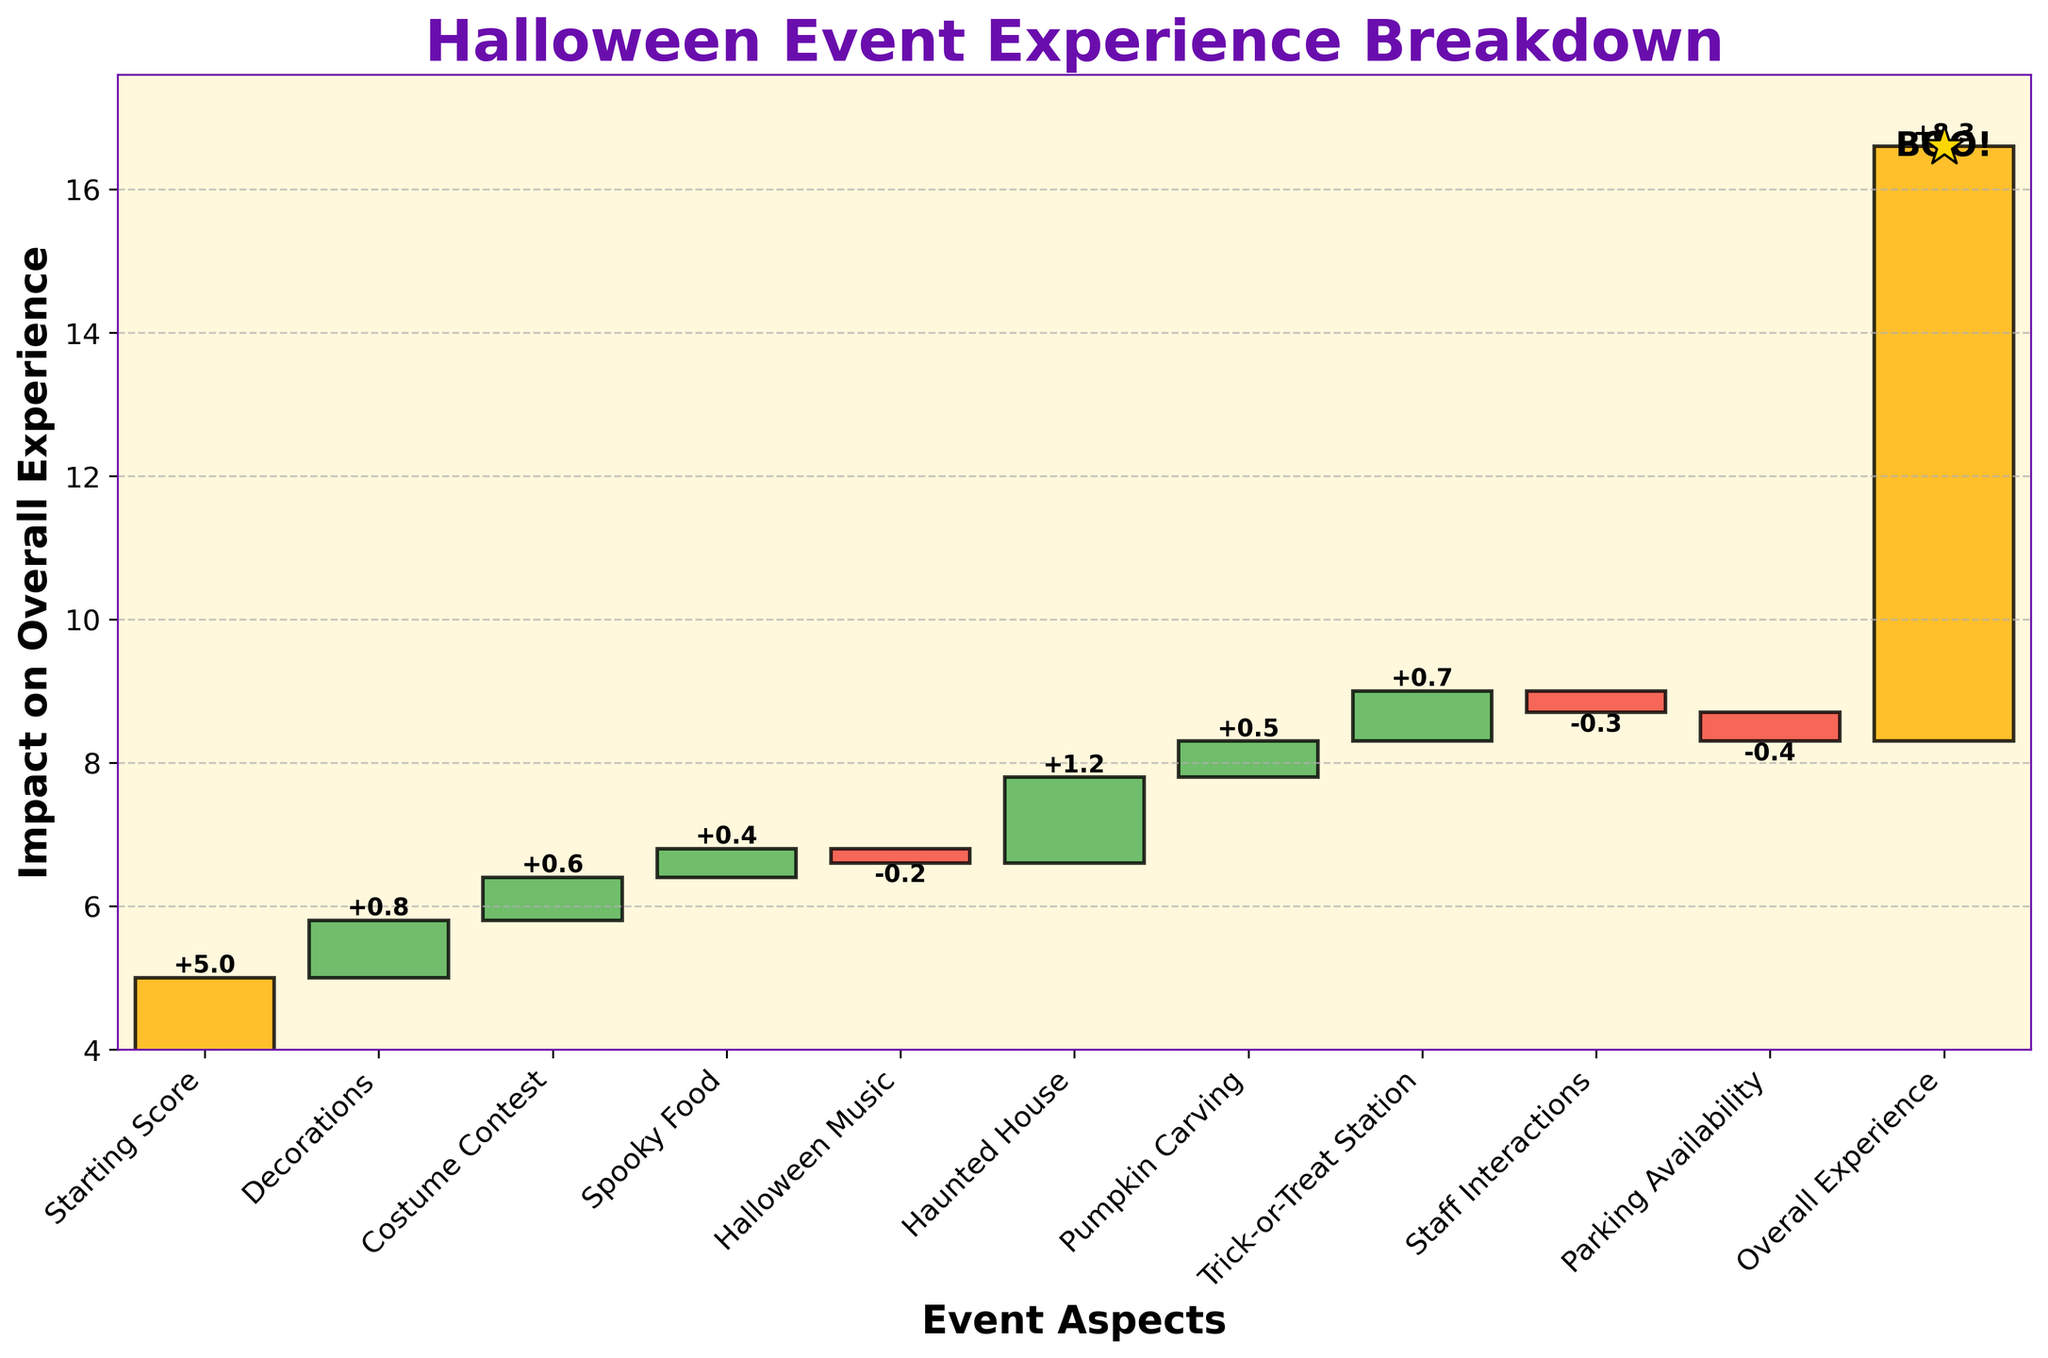What is the title of the chart? The title is usually displayed prominently at the top of the figure. In this chart, it reads "Halloween Event Experience Breakdown".
Answer: Halloween Event Experience Breakdown What is the overall experience score from the chart? The overall experience score is mentioned as one of the categories, specifically as "Overall Experience" with the impact value. The value is noted as 8.3.
Answer: 8.3 Which two categories had negative impacts on the overall experience? By examining the bars on the chart, we identify the categories with red bars as negative impacts. The two categories with negative impact values are "Halloween Music" and "Parking Availability".
Answer: Halloween Music, Parking Availability How many categories contributed positively to the overall experience? Positive contributions are denoted by green bars. Counting the green bars on the chart, there are six contributing positively: "Decorations," "Costume Contest," "Spooky Food," "Haunted House," "Pumpkin Carving," and "Trick-or-Treat Station".
Answer: 6 Which category had the highest positive impact on the overall experience? The highest positive impact is indicated by the tallest green bar. This bar corresponds to the "Haunted House" category with a value of 1.2.
Answer: Haunted House By how much did the "Staff Interactions" category lower the score? The "Staff Interactions" category can be identified on the x-axis, and its impact value is represented by the corresponding red bar. This category lowered the score by -0.3.
Answer: -0.3 What is the difference in impact between "Decorations" and "Parking Availability"? The impact values of "Decorations" and "Parking Availability" need to be compared. "Decorations" is 0.8, and "Parking Availability" is -0.4. The difference is calculated as 0.8 - (-0.4) = 1.2.
Answer: 1.2 What cumulative impact did the first three categories (excluding the Starting Score) have on the experience? Sum the impacts of the first three categories after the Starting Score: "Decorations" (0.8), "Costume Contest" (0.6), and "Spooky Food" (0.4). The cumulative impact is 0.8 + 0.6 + 0.4 = 1.8.
Answer: 1.8 What was the cumulative impact before adding the "Haunted House" category? The "Haunted House" category is the fifth one. Summing the impacts of categories before "Haunted House" (0.8 decor + 0.6 costume + 0.4 food - 0.2 music): 0.8 + 0.6 + 0.4 - 0.2 = 1.6.
Answer: 1.6 Does the "Trick-or-Treat Station" have a higher impact than "Pumpkin Carving"? The impact values for both categories need to be compared. "Trick-or-Treat Station" has an impact of 0.7, while "Pumpkin Carving" has 0.5. Since 0.7 > 0.5, "Trick-or-Treat Station" has a higher impact.
Answer: Yes 